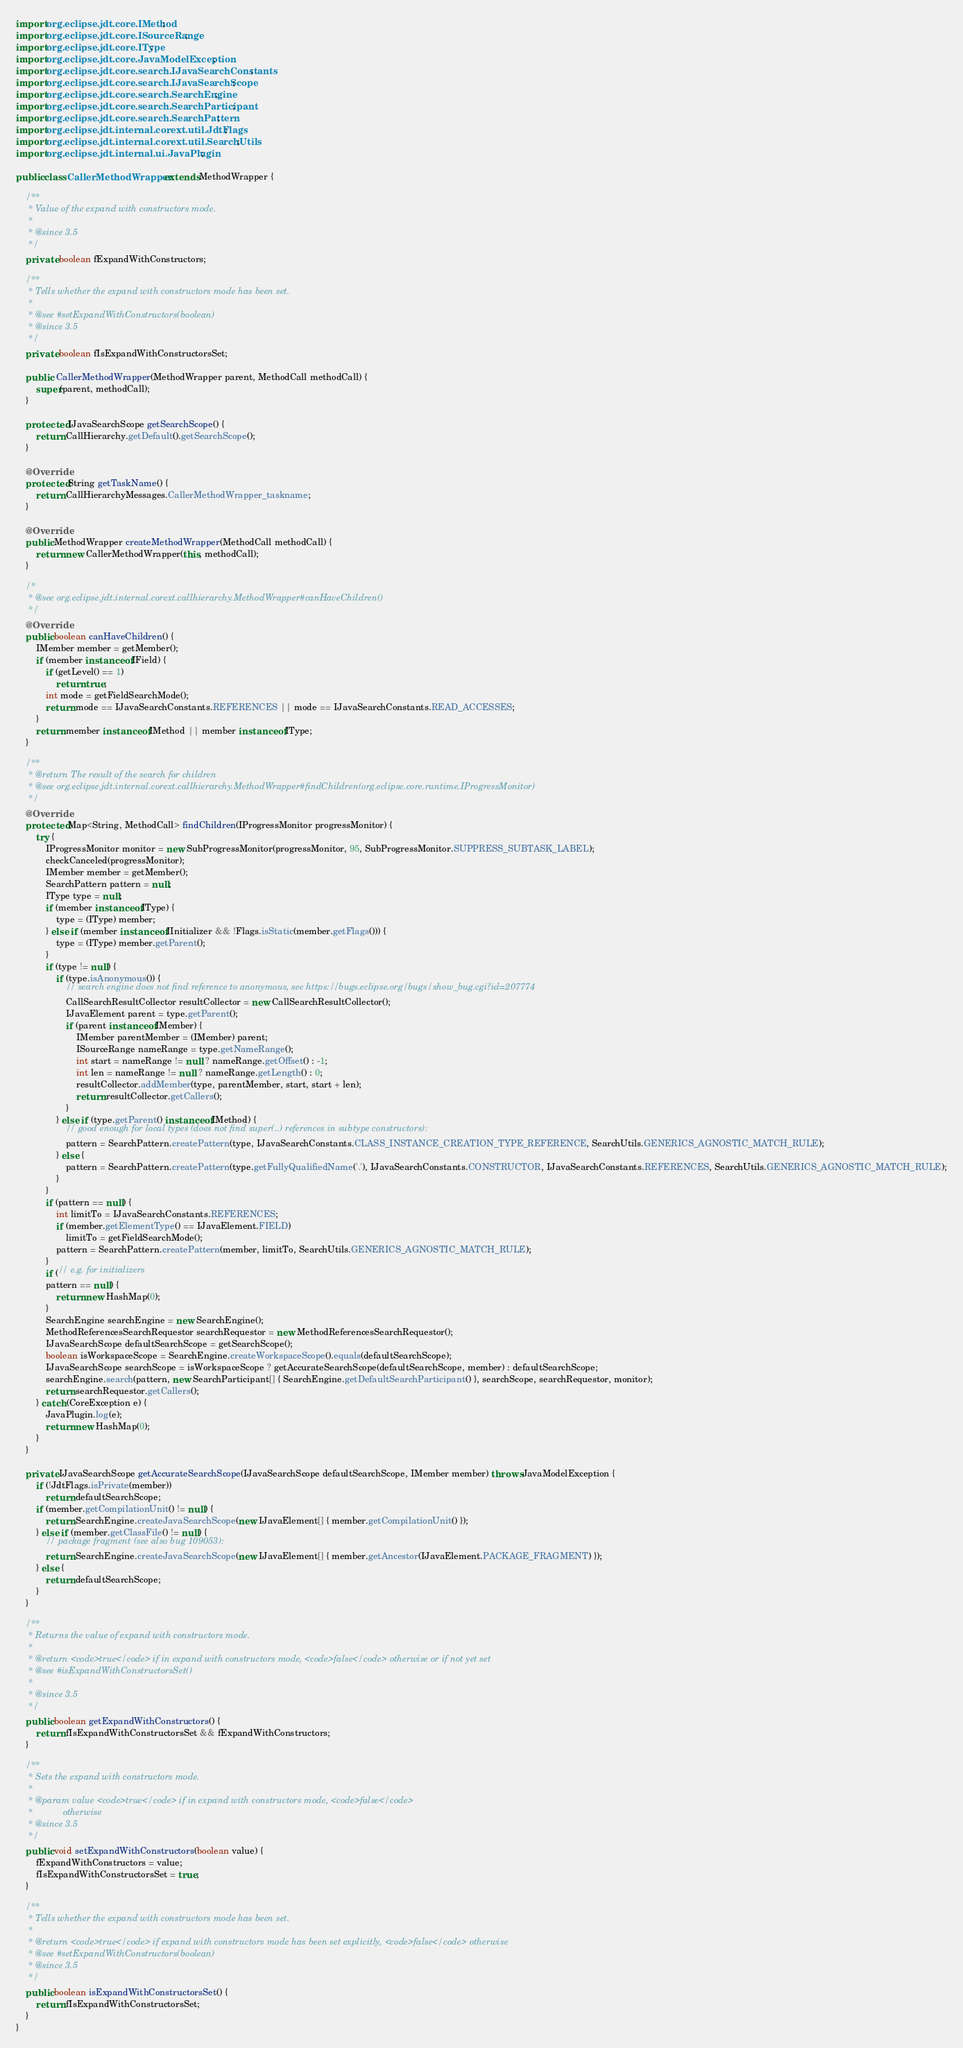Convert code to text. <code><loc_0><loc_0><loc_500><loc_500><_Java_>import org.eclipse.jdt.core.IMethod;
import org.eclipse.jdt.core.ISourceRange;
import org.eclipse.jdt.core.IType;
import org.eclipse.jdt.core.JavaModelException;
import org.eclipse.jdt.core.search.IJavaSearchConstants;
import org.eclipse.jdt.core.search.IJavaSearchScope;
import org.eclipse.jdt.core.search.SearchEngine;
import org.eclipse.jdt.core.search.SearchParticipant;
import org.eclipse.jdt.core.search.SearchPattern;
import org.eclipse.jdt.internal.corext.util.JdtFlags;
import org.eclipse.jdt.internal.corext.util.SearchUtils;
import org.eclipse.jdt.internal.ui.JavaPlugin;

public class CallerMethodWrapper extends MethodWrapper {

    /**
	 * Value of the expand with constructors mode.
	 * 
	 * @since 3.5
	 */
    private boolean fExpandWithConstructors;

    /**
	 * Tells whether the expand with constructors mode has been set.
	 * 
	 * @see #setExpandWithConstructors(boolean)
	 * @since 3.5
	 */
    private boolean fIsExpandWithConstructorsSet;

    public  CallerMethodWrapper(MethodWrapper parent, MethodCall methodCall) {
        super(parent, methodCall);
    }

    protected IJavaSearchScope getSearchScope() {
        return CallHierarchy.getDefault().getSearchScope();
    }

    @Override
    protected String getTaskName() {
        return CallHierarchyMessages.CallerMethodWrapper_taskname;
    }

    @Override
    public MethodWrapper createMethodWrapper(MethodCall methodCall) {
        return new CallerMethodWrapper(this, methodCall);
    }

    /*
	 * @see org.eclipse.jdt.internal.corext.callhierarchy.MethodWrapper#canHaveChildren()
	 */
    @Override
    public boolean canHaveChildren() {
        IMember member = getMember();
        if (member instanceof IField) {
            if (getLevel() == 1)
                return true;
            int mode = getFieldSearchMode();
            return mode == IJavaSearchConstants.REFERENCES || mode == IJavaSearchConstants.READ_ACCESSES;
        }
        return member instanceof IMethod || member instanceof IType;
    }

    /**
	 * @return The result of the search for children
	 * @see org.eclipse.jdt.internal.corext.callhierarchy.MethodWrapper#findChildren(org.eclipse.core.runtime.IProgressMonitor)
	 */
    @Override
    protected Map<String, MethodCall> findChildren(IProgressMonitor progressMonitor) {
        try {
            IProgressMonitor monitor = new SubProgressMonitor(progressMonitor, 95, SubProgressMonitor.SUPPRESS_SUBTASK_LABEL);
            checkCanceled(progressMonitor);
            IMember member = getMember();
            SearchPattern pattern = null;
            IType type = null;
            if (member instanceof IType) {
                type = (IType) member;
            } else if (member instanceof IInitializer && !Flags.isStatic(member.getFlags())) {
                type = (IType) member.getParent();
            }
            if (type != null) {
                if (type.isAnonymous()) {
                    // search engine does not find reference to anonymous, see https://bugs.eclipse.org/bugs/show_bug.cgi?id=207774
                    CallSearchResultCollector resultCollector = new CallSearchResultCollector();
                    IJavaElement parent = type.getParent();
                    if (parent instanceof IMember) {
                        IMember parentMember = (IMember) parent;
                        ISourceRange nameRange = type.getNameRange();
                        int start = nameRange != null ? nameRange.getOffset() : -1;
                        int len = nameRange != null ? nameRange.getLength() : 0;
                        resultCollector.addMember(type, parentMember, start, start + len);
                        return resultCollector.getCallers();
                    }
                } else if (type.getParent() instanceof IMethod) {
                    // good enough for local types (does not find super(..) references in subtype constructors):
                    pattern = SearchPattern.createPattern(type, IJavaSearchConstants.CLASS_INSTANCE_CREATION_TYPE_REFERENCE, SearchUtils.GENERICS_AGNOSTIC_MATCH_RULE);
                } else {
                    pattern = SearchPattern.createPattern(type.getFullyQualifiedName('.'), IJavaSearchConstants.CONSTRUCTOR, IJavaSearchConstants.REFERENCES, SearchUtils.GENERICS_AGNOSTIC_MATCH_RULE);
                }
            }
            if (pattern == null) {
                int limitTo = IJavaSearchConstants.REFERENCES;
                if (member.getElementType() == IJavaElement.FIELD)
                    limitTo = getFieldSearchMode();
                pattern = SearchPattern.createPattern(member, limitTo, SearchUtils.GENERICS_AGNOSTIC_MATCH_RULE);
            }
            if (// e.g. for initializers
            pattern == null) {
                return new HashMap(0);
            }
            SearchEngine searchEngine = new SearchEngine();
            MethodReferencesSearchRequestor searchRequestor = new MethodReferencesSearchRequestor();
            IJavaSearchScope defaultSearchScope = getSearchScope();
            boolean isWorkspaceScope = SearchEngine.createWorkspaceScope().equals(defaultSearchScope);
            IJavaSearchScope searchScope = isWorkspaceScope ? getAccurateSearchScope(defaultSearchScope, member) : defaultSearchScope;
            searchEngine.search(pattern, new SearchParticipant[] { SearchEngine.getDefaultSearchParticipant() }, searchScope, searchRequestor, monitor);
            return searchRequestor.getCallers();
        } catch (CoreException e) {
            JavaPlugin.log(e);
            return new HashMap(0);
        }
    }

    private IJavaSearchScope getAccurateSearchScope(IJavaSearchScope defaultSearchScope, IMember member) throws JavaModelException {
        if (!JdtFlags.isPrivate(member))
            return defaultSearchScope;
        if (member.getCompilationUnit() != null) {
            return SearchEngine.createJavaSearchScope(new IJavaElement[] { member.getCompilationUnit() });
        } else if (member.getClassFile() != null) {
            // package fragment (see also bug 109053):
            return SearchEngine.createJavaSearchScope(new IJavaElement[] { member.getAncestor(IJavaElement.PACKAGE_FRAGMENT) });
        } else {
            return defaultSearchScope;
        }
    }

    /**
	 * Returns the value of expand with constructors mode.
	 * 
	 * @return <code>true</code> if in expand with constructors mode, <code>false</code> otherwise or if not yet set
	 * @see #isExpandWithConstructorsSet()
	 * 
	 * @since 3.5
	 */
    public boolean getExpandWithConstructors() {
        return fIsExpandWithConstructorsSet && fExpandWithConstructors;
    }

    /**
	 * Sets the expand with constructors mode.
	 * 
	 * @param value <code>true</code> if in expand with constructors mode, <code>false</code>
	 *            otherwise
	 * @since 3.5
	 */
    public void setExpandWithConstructors(boolean value) {
        fExpandWithConstructors = value;
        fIsExpandWithConstructorsSet = true;
    }

    /**
	 * Tells whether the expand with constructors mode has been set.
	 * 
	 * @return <code>true</code> if expand with constructors mode has been set explicitly, <code>false</code> otherwise
	 * @see #setExpandWithConstructors(boolean)
	 * @since 3.5
	 */
    public boolean isExpandWithConstructorsSet() {
        return fIsExpandWithConstructorsSet;
    }
}
</code> 